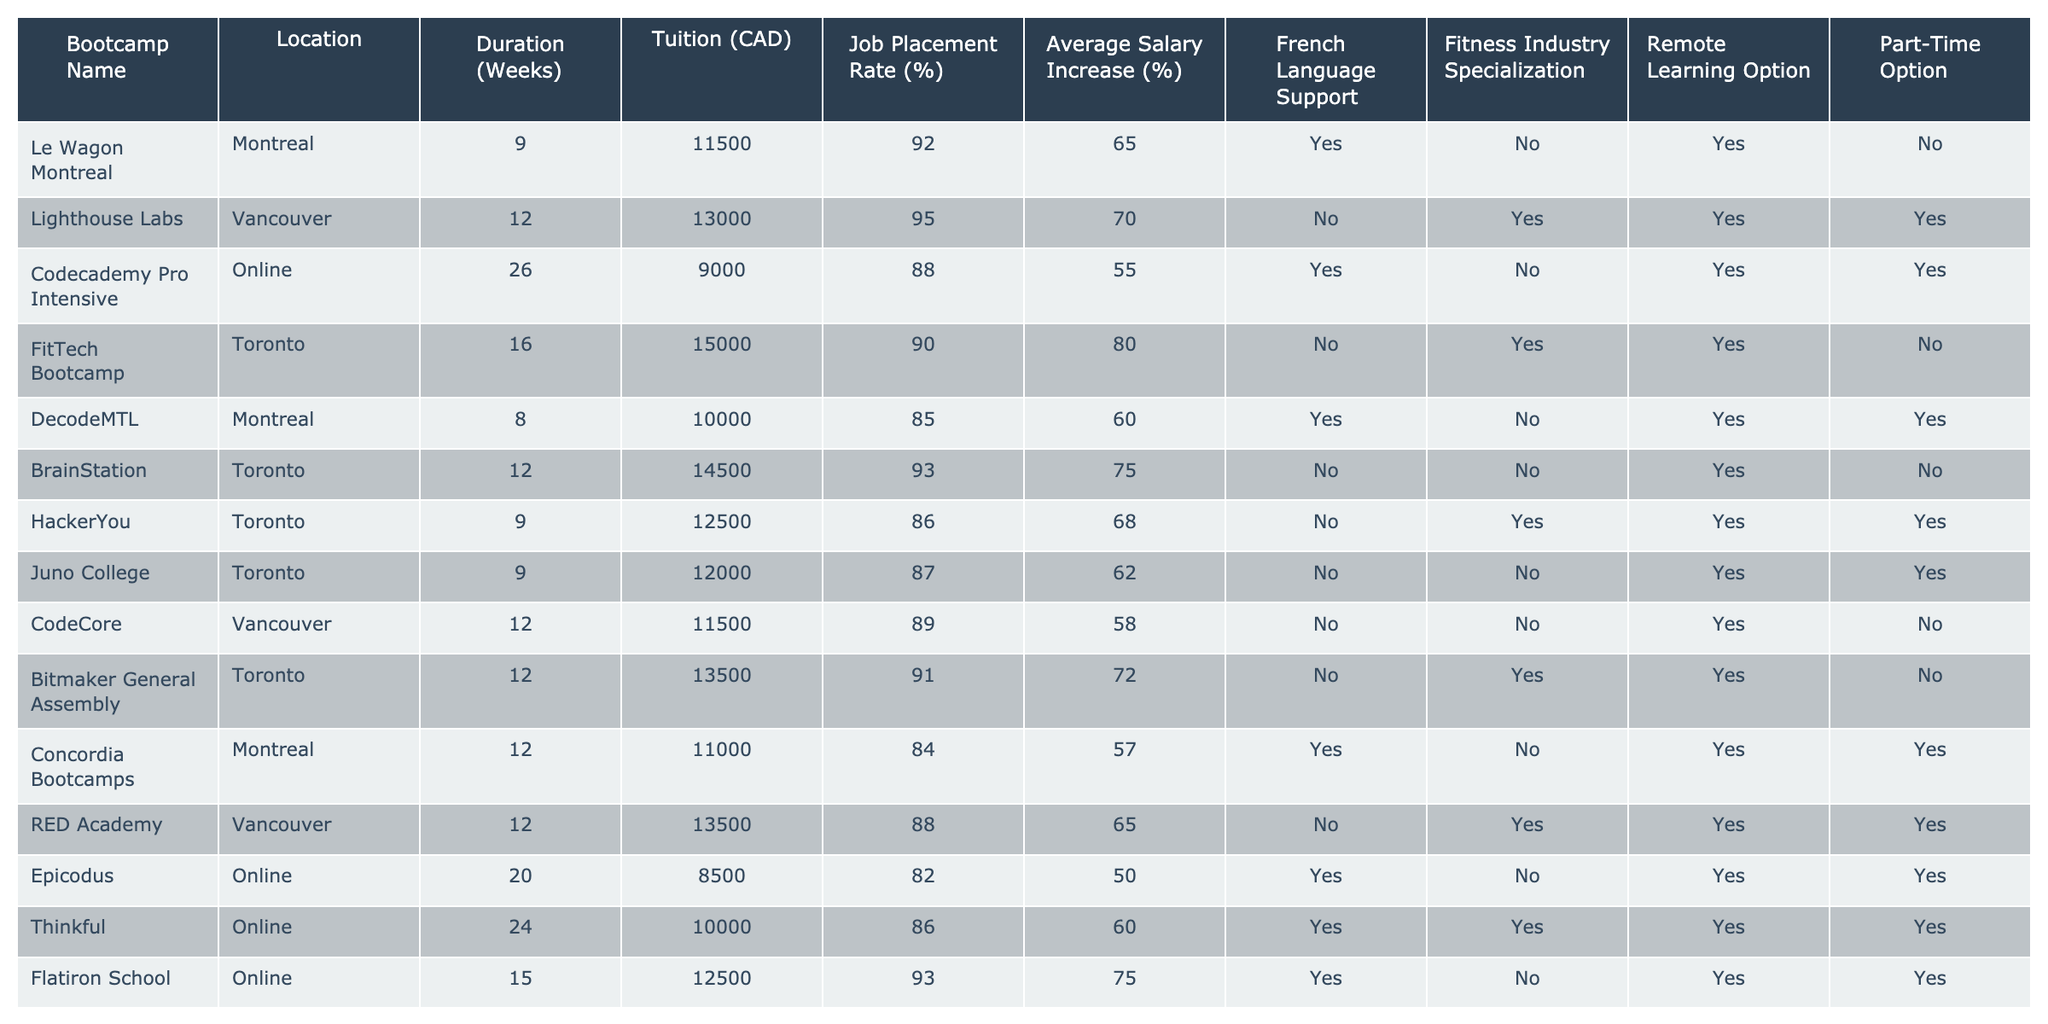What is the job placement rate for the Codecademy Pro Intensive bootcamp? The job placement rate for the Codecademy Pro Intensive bootcamp is listed in the table as 88%.
Answer: 88% Which bootcamp has the lowest tuition fee? By comparing the tuition values listed for each bootcamp, Codecademy Pro Intensive has the lowest tuition fee of 9000 CAD.
Answer: 9000 CAD How many weeks does the Le Wagon Montreal bootcamp last? The duration for Le Wagon Montreal bootcamp is mentioned in the table as 9 weeks.
Answer: 9 weeks Is there a bootcamp that offers both French language support and a remote learning option? Looking at the table, Flatiron School, Thinkful, and Codecademy Pro Intensive all have "Yes" for French support and "Yes" for remote learning option.
Answer: Yes What is the average salary increase for fitness professionals who attend the Lighthouse Labs bootcamp? The average salary increase for Lighthouse Labs is given as 70% in the table.
Answer: 70% Which bootcamp located in Montreal has the best job placement rate? From the table, Le Wagon Montreal has a job placement rate of 92%, while DecodeMTL has 85% and Concordia Bootcamps has 84%. So, Le Wagon Montreal has the highest job placement rate in Montreal.
Answer: Le Wagon Montreal What is the difference in job placement rates between the FitTech Bootcamp and the HackerYou bootcamp? FitTech Bootcamp has a job placement rate of 90%, and HackerYou has 86%. The difference is calculated as 90% - 86% = 4%.
Answer: 4% How many bootcamps provide part-time options? By checking the table, there are 6 bootcamps that offer part-time options (Lighthouse Labs, HackerYou, Juno College, Bitmaker General Assembly, RED Academy, and Thinkful).
Answer: 6 Which bootcamp offers the highest average salary increase and what is that percentage? By examining the average salary increase values, FitTech Bootcamp has the highest percentage at 80%.
Answer: 80% Is there a bootcamp that does not provide French language support or a fitness industry specialization? Analyzing the table shows that BrainStation and CodeCore do not provide French language support or a fitness industry specialization.
Answer: Yes What is the average tuition fee of all bootcamps listed in the table? To find the average tuition, we sum the tuition fees: (11500 + 13000 + 9000 + 15000 + 10000 + 14500 + 12500 + 12000 + 11500 + 13500 + 11000 + 13500 + 8500 + 10000 + 12500) =  161500, and dividing by the number of bootcamps (15): 161500 / 15 = 10766.67.
Answer: 10766.67 CAD 